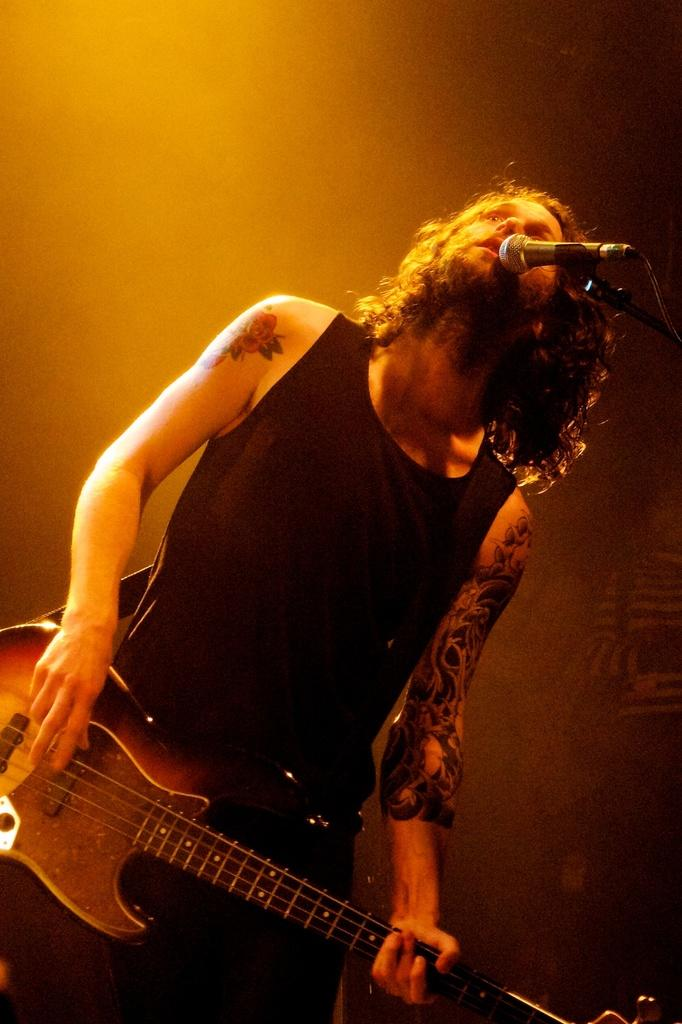What is the main subject of the image? There is a person in the image. What is the person doing in the image? The person is standing in front of a mic. What object is the person holding in the image? The person is holding a guitar. What type of juice is the person drinking from the basin in the image? There is no juice or basin present in the image; the person is holding a guitar and standing in front of a mic. 